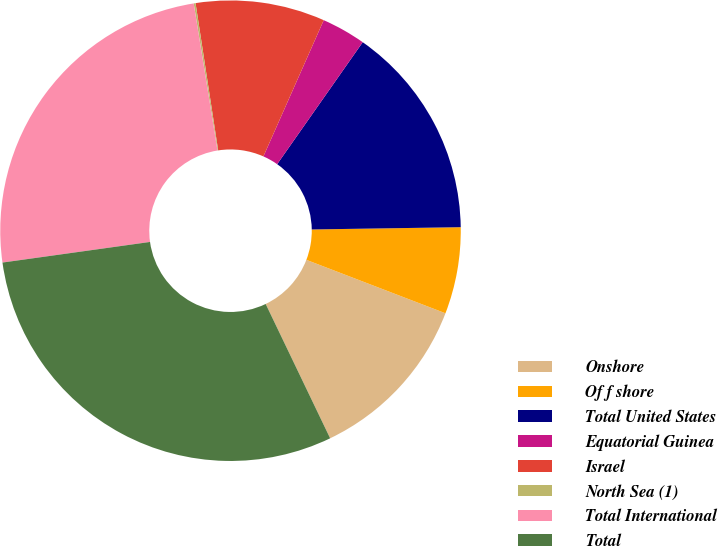Convert chart to OTSL. <chart><loc_0><loc_0><loc_500><loc_500><pie_chart><fcel>Onshore<fcel>Of f shore<fcel>Total United States<fcel>Equatorial Guinea<fcel>Israel<fcel>North Sea (1)<fcel>Total International<fcel>Total<nl><fcel>12.04%<fcel>6.08%<fcel>15.02%<fcel>3.1%<fcel>9.06%<fcel>0.13%<fcel>24.65%<fcel>29.91%<nl></chart> 